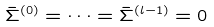Convert formula to latex. <formula><loc_0><loc_0><loc_500><loc_500>\bar { \Sigma } ^ { ( 0 ) } = \cdots = \bar { \Sigma } ^ { ( l - 1 ) } = 0</formula> 